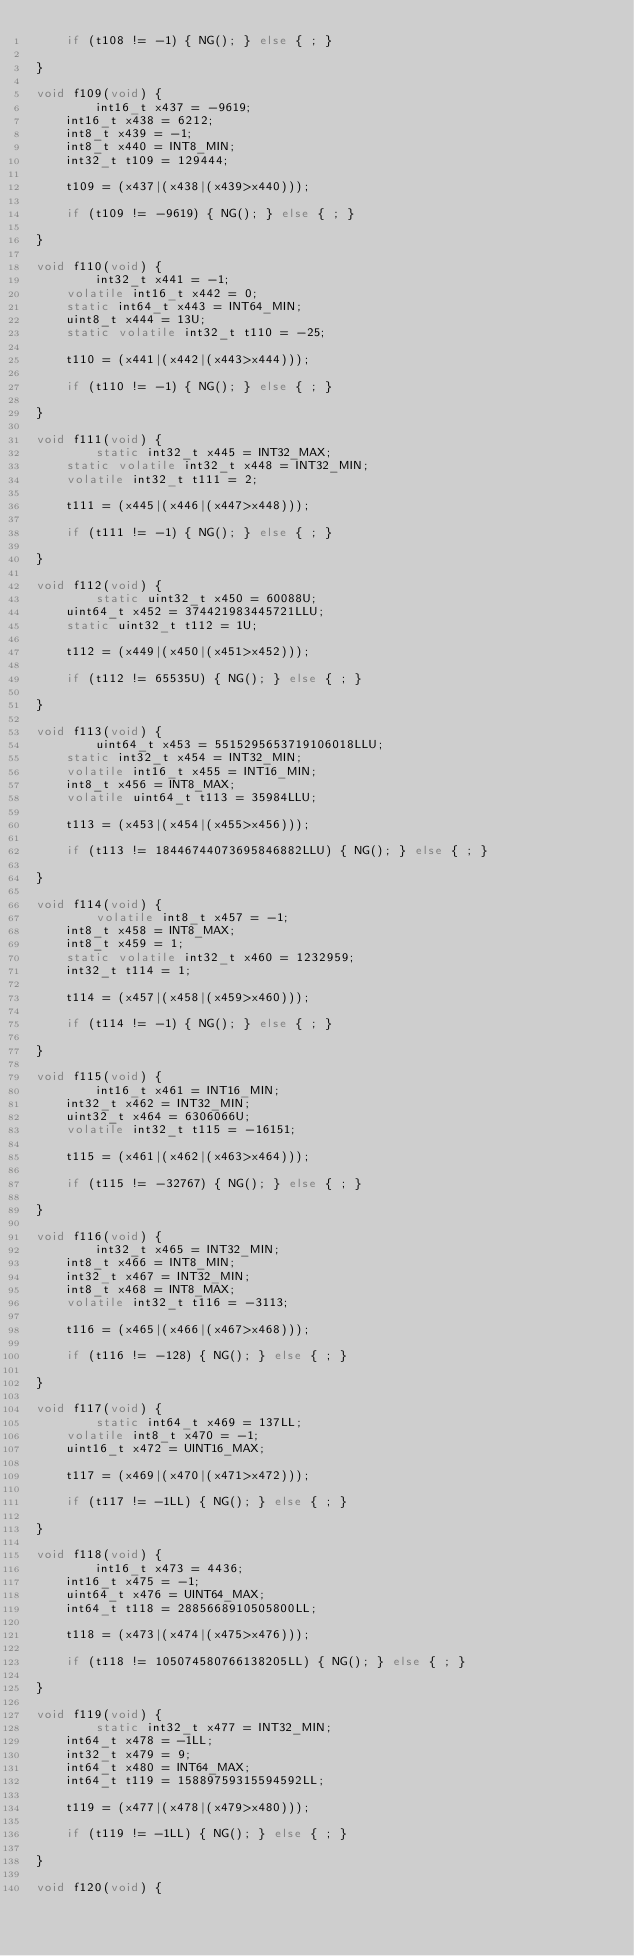<code> <loc_0><loc_0><loc_500><loc_500><_C_>    if (t108 != -1) { NG(); } else { ; }
	
}

void f109(void) {
    	int16_t x437 = -9619;
	int16_t x438 = 6212;
	int8_t x439 = -1;
	int8_t x440 = INT8_MIN;
	int32_t t109 = 129444;

    t109 = (x437|(x438|(x439>x440)));

    if (t109 != -9619) { NG(); } else { ; }
	
}

void f110(void) {
    	int32_t x441 = -1;
	volatile int16_t x442 = 0;
	static int64_t x443 = INT64_MIN;
	uint8_t x444 = 13U;
	static volatile int32_t t110 = -25;

    t110 = (x441|(x442|(x443>x444)));

    if (t110 != -1) { NG(); } else { ; }
	
}

void f111(void) {
    	static int32_t x445 = INT32_MAX;
	static volatile int32_t x448 = INT32_MIN;
	volatile int32_t t111 = 2;

    t111 = (x445|(x446|(x447>x448)));

    if (t111 != -1) { NG(); } else { ; }
	
}

void f112(void) {
    	static uint32_t x450 = 60088U;
	uint64_t x452 = 374421983445721LLU;
	static uint32_t t112 = 1U;

    t112 = (x449|(x450|(x451>x452)));

    if (t112 != 65535U) { NG(); } else { ; }
	
}

void f113(void) {
    	uint64_t x453 = 5515295653719106018LLU;
	static int32_t x454 = INT32_MIN;
	volatile int16_t x455 = INT16_MIN;
	int8_t x456 = INT8_MAX;
	volatile uint64_t t113 = 35984LLU;

    t113 = (x453|(x454|(x455>x456)));

    if (t113 != 18446744073695846882LLU) { NG(); } else { ; }
	
}

void f114(void) {
    	volatile int8_t x457 = -1;
	int8_t x458 = INT8_MAX;
	int8_t x459 = 1;
	static volatile int32_t x460 = 1232959;
	int32_t t114 = 1;

    t114 = (x457|(x458|(x459>x460)));

    if (t114 != -1) { NG(); } else { ; }
	
}

void f115(void) {
    	int16_t x461 = INT16_MIN;
	int32_t x462 = INT32_MIN;
	uint32_t x464 = 6306066U;
	volatile int32_t t115 = -16151;

    t115 = (x461|(x462|(x463>x464)));

    if (t115 != -32767) { NG(); } else { ; }
	
}

void f116(void) {
    	int32_t x465 = INT32_MIN;
	int8_t x466 = INT8_MIN;
	int32_t x467 = INT32_MIN;
	int8_t x468 = INT8_MAX;
	volatile int32_t t116 = -3113;

    t116 = (x465|(x466|(x467>x468)));

    if (t116 != -128) { NG(); } else { ; }
	
}

void f117(void) {
    	static int64_t x469 = 137LL;
	volatile int8_t x470 = -1;
	uint16_t x472 = UINT16_MAX;

    t117 = (x469|(x470|(x471>x472)));

    if (t117 != -1LL) { NG(); } else { ; }
	
}

void f118(void) {
    	int16_t x473 = 4436;
	int16_t x475 = -1;
	uint64_t x476 = UINT64_MAX;
	int64_t t118 = 2885668910505800LL;

    t118 = (x473|(x474|(x475>x476)));

    if (t118 != 105074580766138205LL) { NG(); } else { ; }
	
}

void f119(void) {
    	static int32_t x477 = INT32_MIN;
	int64_t x478 = -1LL;
	int32_t x479 = 9;
	int64_t x480 = INT64_MAX;
	int64_t t119 = 15889759315594592LL;

    t119 = (x477|(x478|(x479>x480)));

    if (t119 != -1LL) { NG(); } else { ; }
	
}

void f120(void) {</code> 